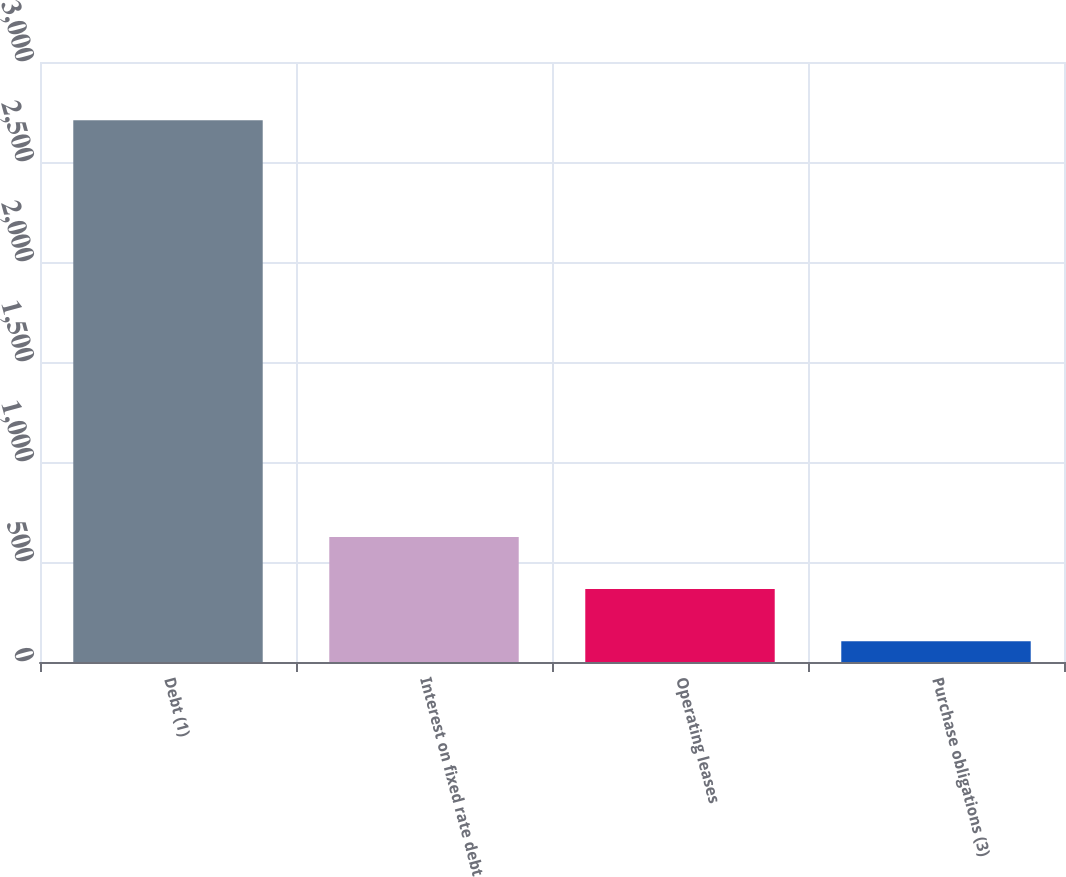<chart> <loc_0><loc_0><loc_500><loc_500><bar_chart><fcel>Debt (1)<fcel>Interest on fixed rate debt<fcel>Operating leases<fcel>Purchase obligations (3)<nl><fcel>2709<fcel>625<fcel>364.5<fcel>104<nl></chart> 